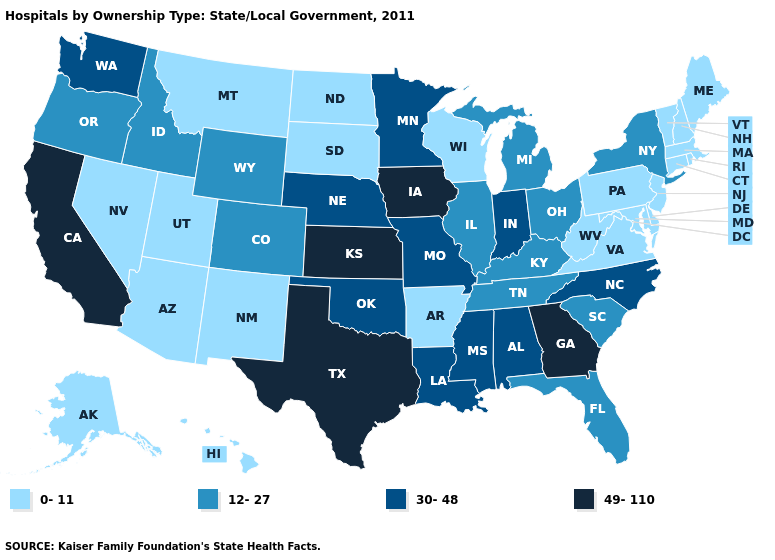Does Ohio have the same value as Oregon?
Short answer required. Yes. What is the value of Delaware?
Write a very short answer. 0-11. Does South Carolina have a lower value than Montana?
Be succinct. No. Does the first symbol in the legend represent the smallest category?
Quick response, please. Yes. Name the states that have a value in the range 12-27?
Short answer required. Colorado, Florida, Idaho, Illinois, Kentucky, Michigan, New York, Ohio, Oregon, South Carolina, Tennessee, Wyoming. Which states have the highest value in the USA?
Give a very brief answer. California, Georgia, Iowa, Kansas, Texas. Does New Jersey have the same value as Indiana?
Be succinct. No. Which states hav the highest value in the MidWest?
Keep it brief. Iowa, Kansas. Which states hav the highest value in the South?
Concise answer only. Georgia, Texas. Name the states that have a value in the range 30-48?
Give a very brief answer. Alabama, Indiana, Louisiana, Minnesota, Mississippi, Missouri, Nebraska, North Carolina, Oklahoma, Washington. Among the states that border California , which have the lowest value?
Keep it brief. Arizona, Nevada. What is the value of Minnesota?
Keep it brief. 30-48. Among the states that border Pennsylvania , which have the highest value?
Give a very brief answer. New York, Ohio. Which states have the lowest value in the USA?
Write a very short answer. Alaska, Arizona, Arkansas, Connecticut, Delaware, Hawaii, Maine, Maryland, Massachusetts, Montana, Nevada, New Hampshire, New Jersey, New Mexico, North Dakota, Pennsylvania, Rhode Island, South Dakota, Utah, Vermont, Virginia, West Virginia, Wisconsin. What is the value of Alabama?
Short answer required. 30-48. 